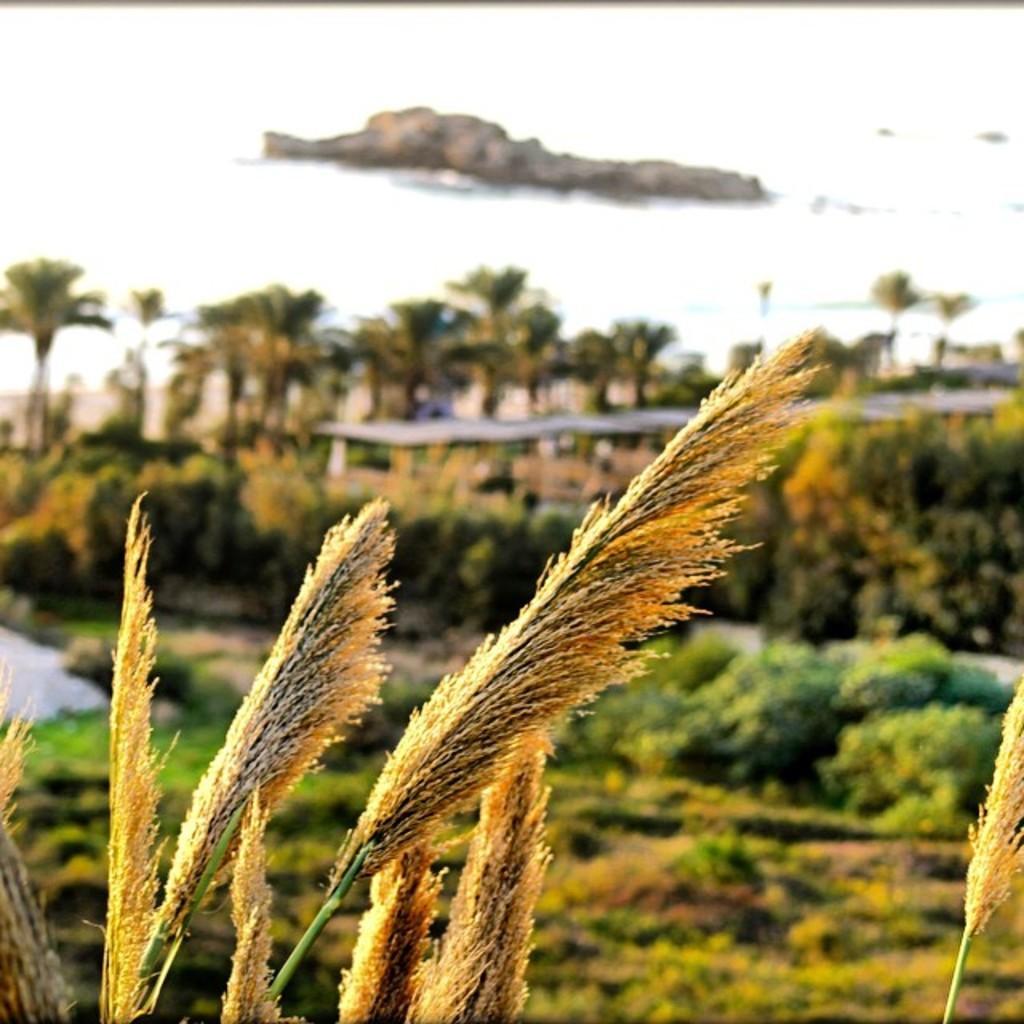Can you describe this image briefly? This picture shows few trees and we see water and a rock. 